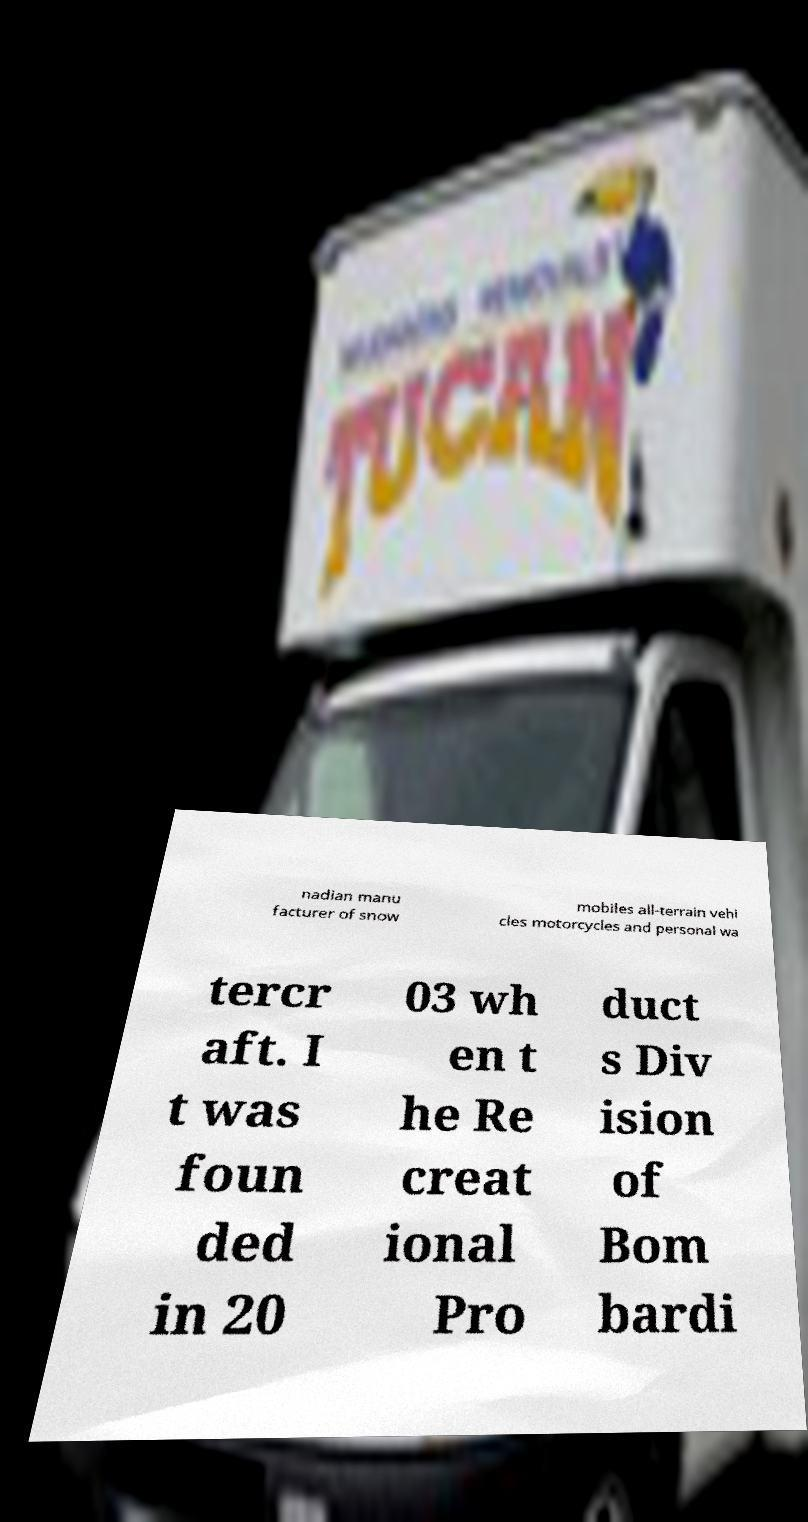Could you extract and type out the text from this image? nadian manu facturer of snow mobiles all-terrain vehi cles motorcycles and personal wa tercr aft. I t was foun ded in 20 03 wh en t he Re creat ional Pro duct s Div ision of Bom bardi 